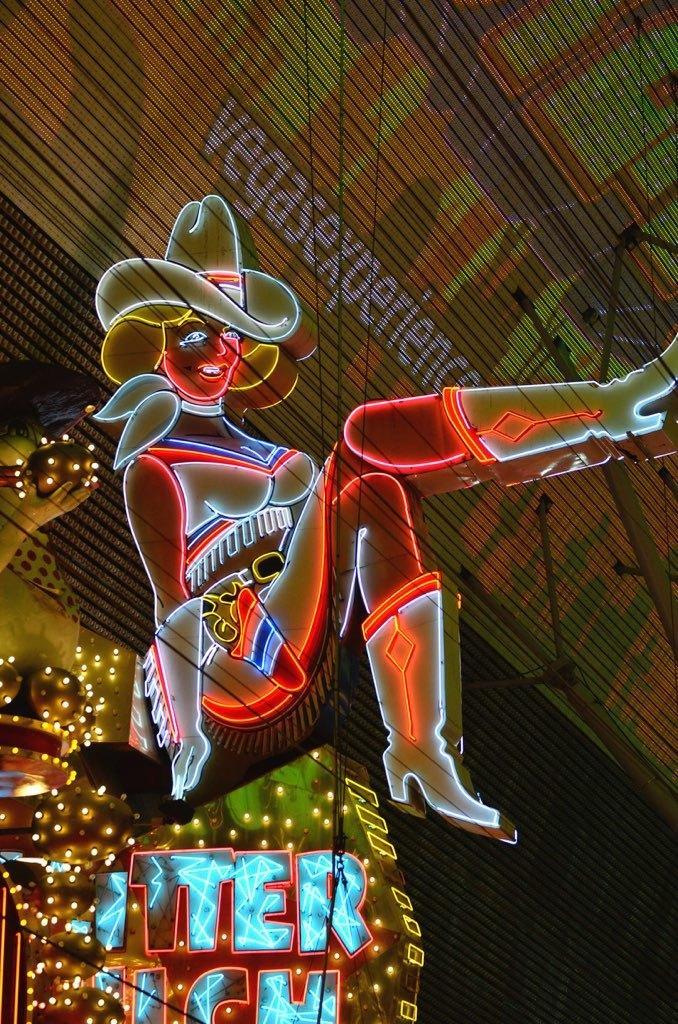How would you summarize this image in a sentence or two? In the center of the image we can see decoration light of a person. At the bottom of the image we can see alphabets lights. In the background of the image we can see text, wires, poles and wall. 